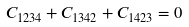Convert formula to latex. <formula><loc_0><loc_0><loc_500><loc_500>C _ { 1 2 3 4 } + C _ { 1 3 4 2 } + C _ { 1 4 2 3 } = 0</formula> 